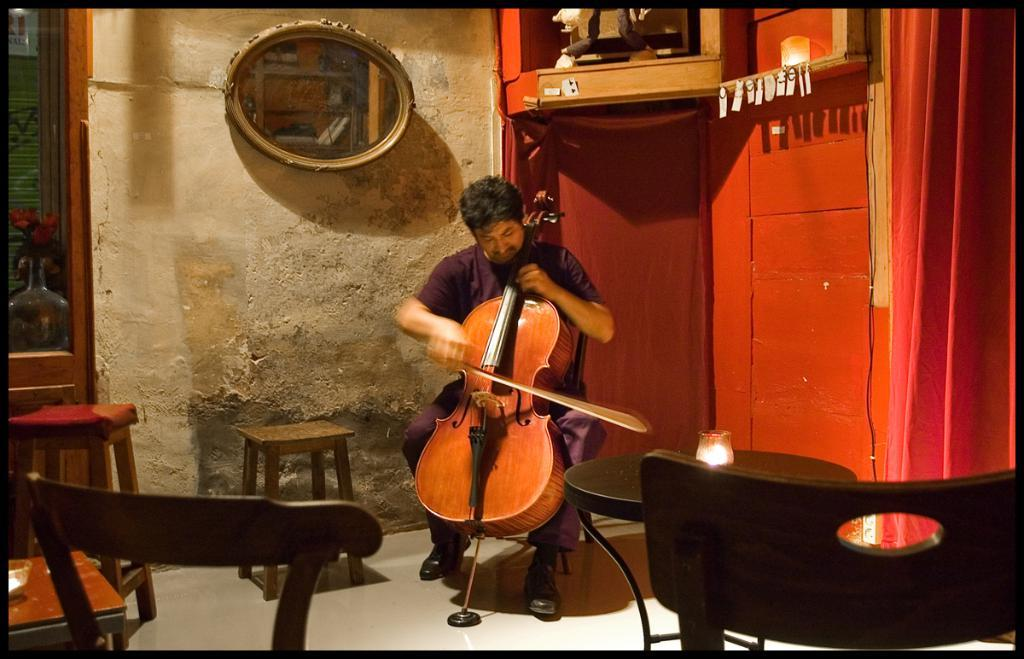What is the person in the image doing? The person is sitting and playing a guitar. What can be seen in the background of the image? There is a mirror, a door, a curtain, a chair, a table, and a glass in the background. Can you describe the objects in the background? The mirror is reflective, the door is likely for entering or exiting the room, the curtain is a fabric covering a window or doorway, the chair is a place to sit, the table is a surface for placing objects, and the glass is a container for holding liquids. What type of attention is the person receiving while playing volleyball in the image? There is no volleyball present in the image; the person is playing a guitar. How many trucks are visible in the image? There are no trucks visible in the image. 